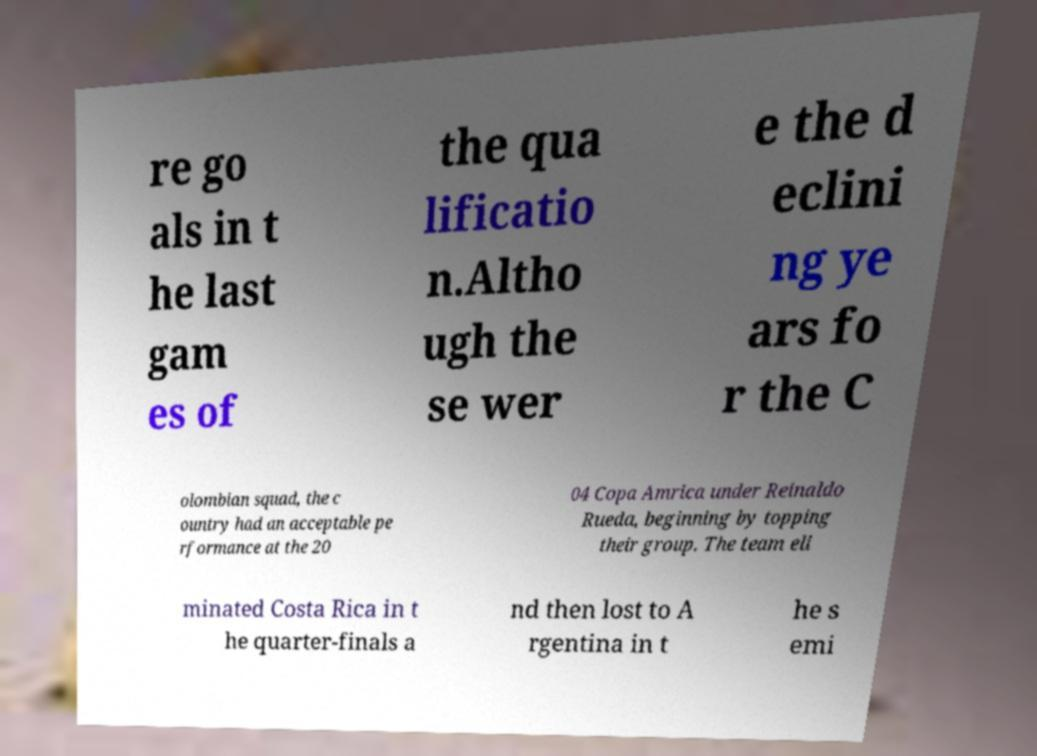Can you read and provide the text displayed in the image?This photo seems to have some interesting text. Can you extract and type it out for me? re go als in t he last gam es of the qua lificatio n.Altho ugh the se wer e the d eclini ng ye ars fo r the C olombian squad, the c ountry had an acceptable pe rformance at the 20 04 Copa Amrica under Reinaldo Rueda, beginning by topping their group. The team eli minated Costa Rica in t he quarter-finals a nd then lost to A rgentina in t he s emi 